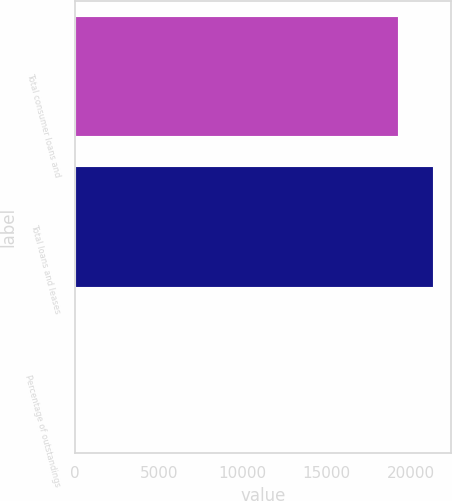<chart> <loc_0><loc_0><loc_500><loc_500><bar_chart><fcel>Total consumer loans and<fcel>Total loans and leases<fcel>Percentage of outstandings<nl><fcel>19275<fcel>21350.3<fcel>2.3<nl></chart> 